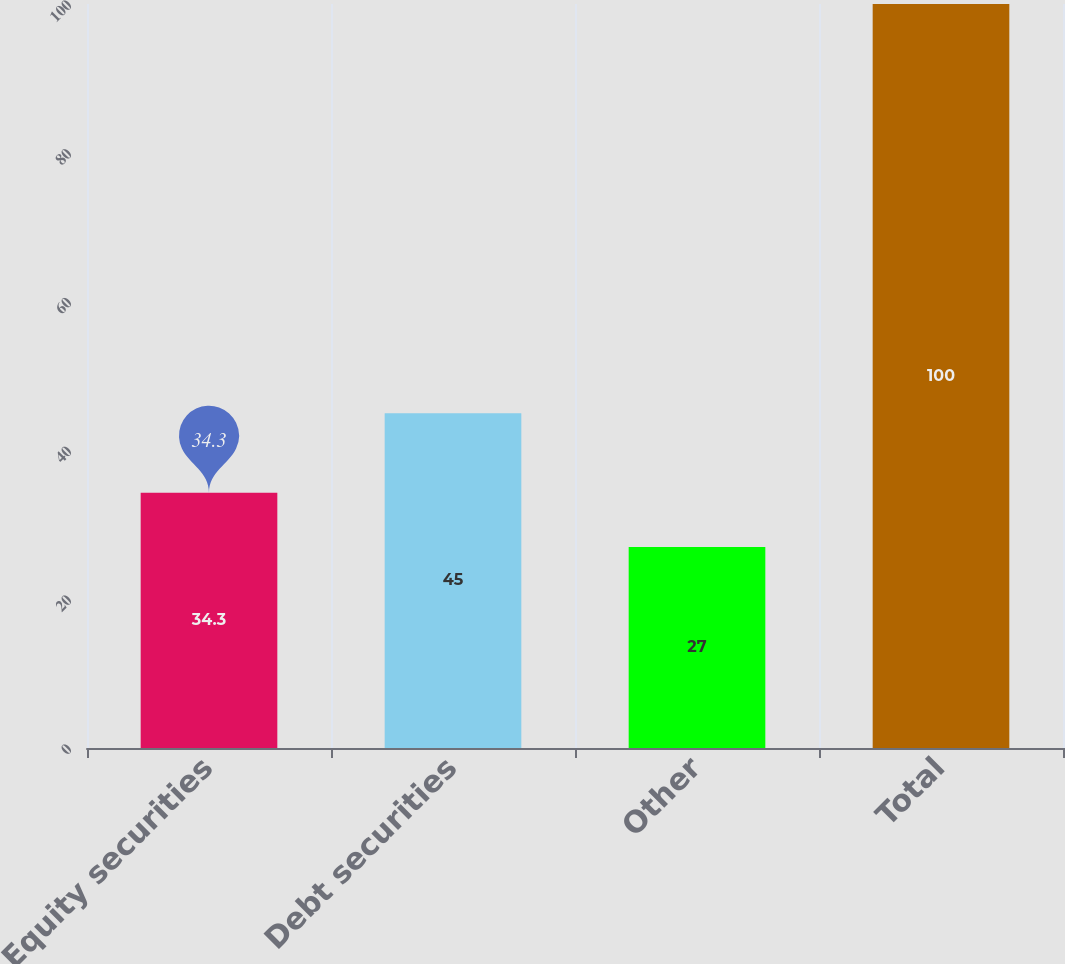Convert chart to OTSL. <chart><loc_0><loc_0><loc_500><loc_500><bar_chart><fcel>Equity securities<fcel>Debt securities<fcel>Other<fcel>Total<nl><fcel>34.3<fcel>45<fcel>27<fcel>100<nl></chart> 